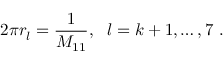<formula> <loc_0><loc_0><loc_500><loc_500>2 \pi r _ { l } = \frac { 1 } { M _ { 1 1 } } , l = k + 1 , \dots , 7 \ .</formula> 